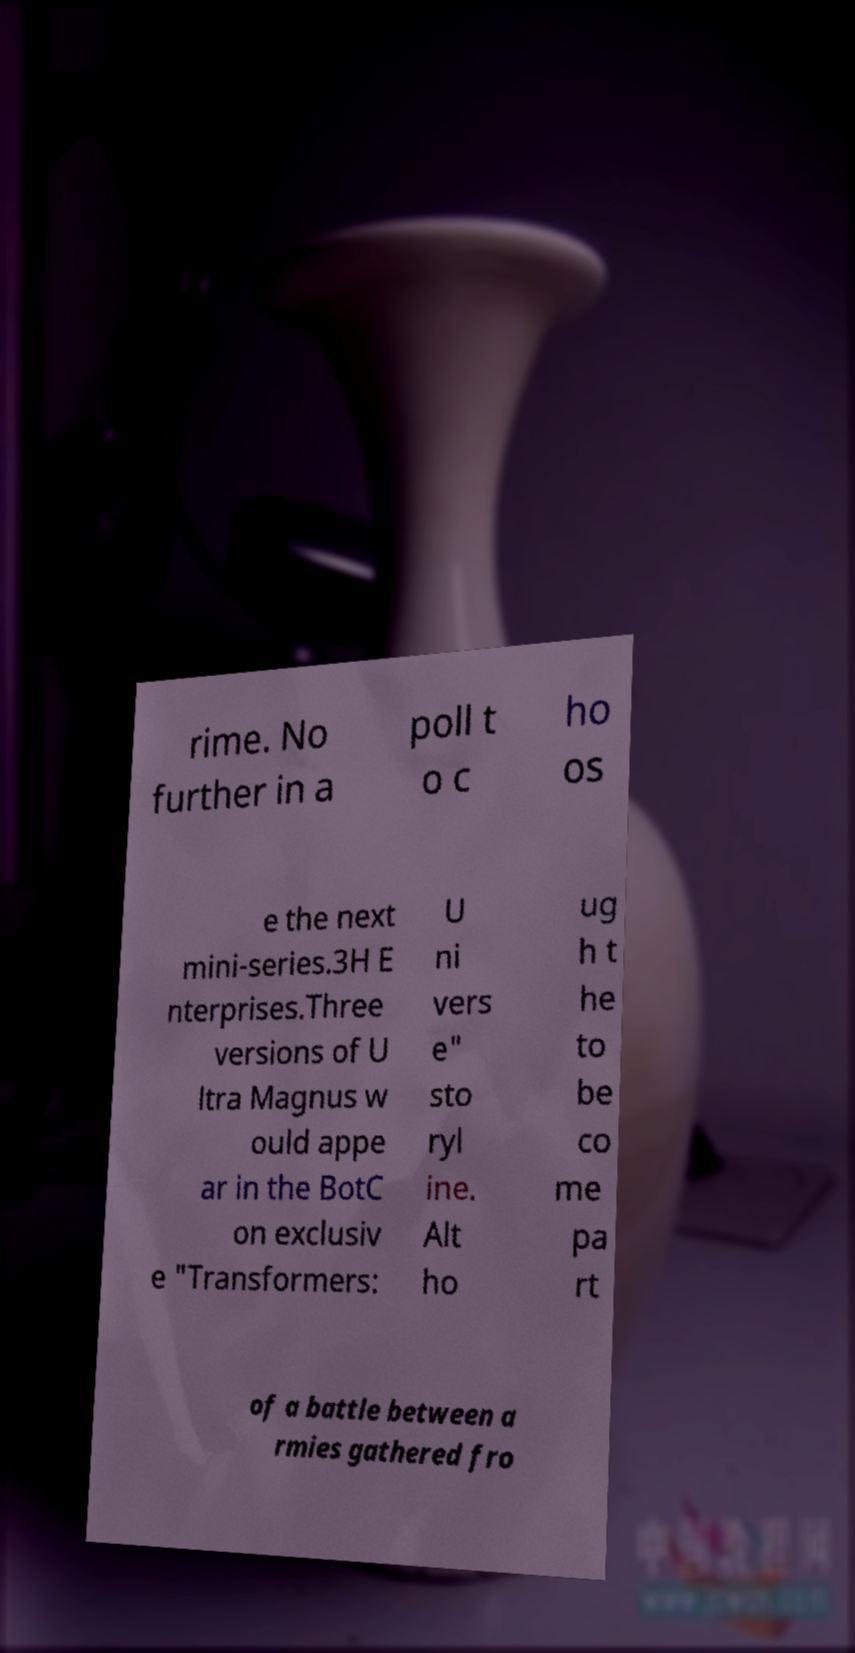Can you read and provide the text displayed in the image?This photo seems to have some interesting text. Can you extract and type it out for me? rime. No further in a poll t o c ho os e the next mini-series.3H E nterprises.Three versions of U ltra Magnus w ould appe ar in the BotC on exclusiv e "Transformers: U ni vers e" sto ryl ine. Alt ho ug h t he to be co me pa rt of a battle between a rmies gathered fro 